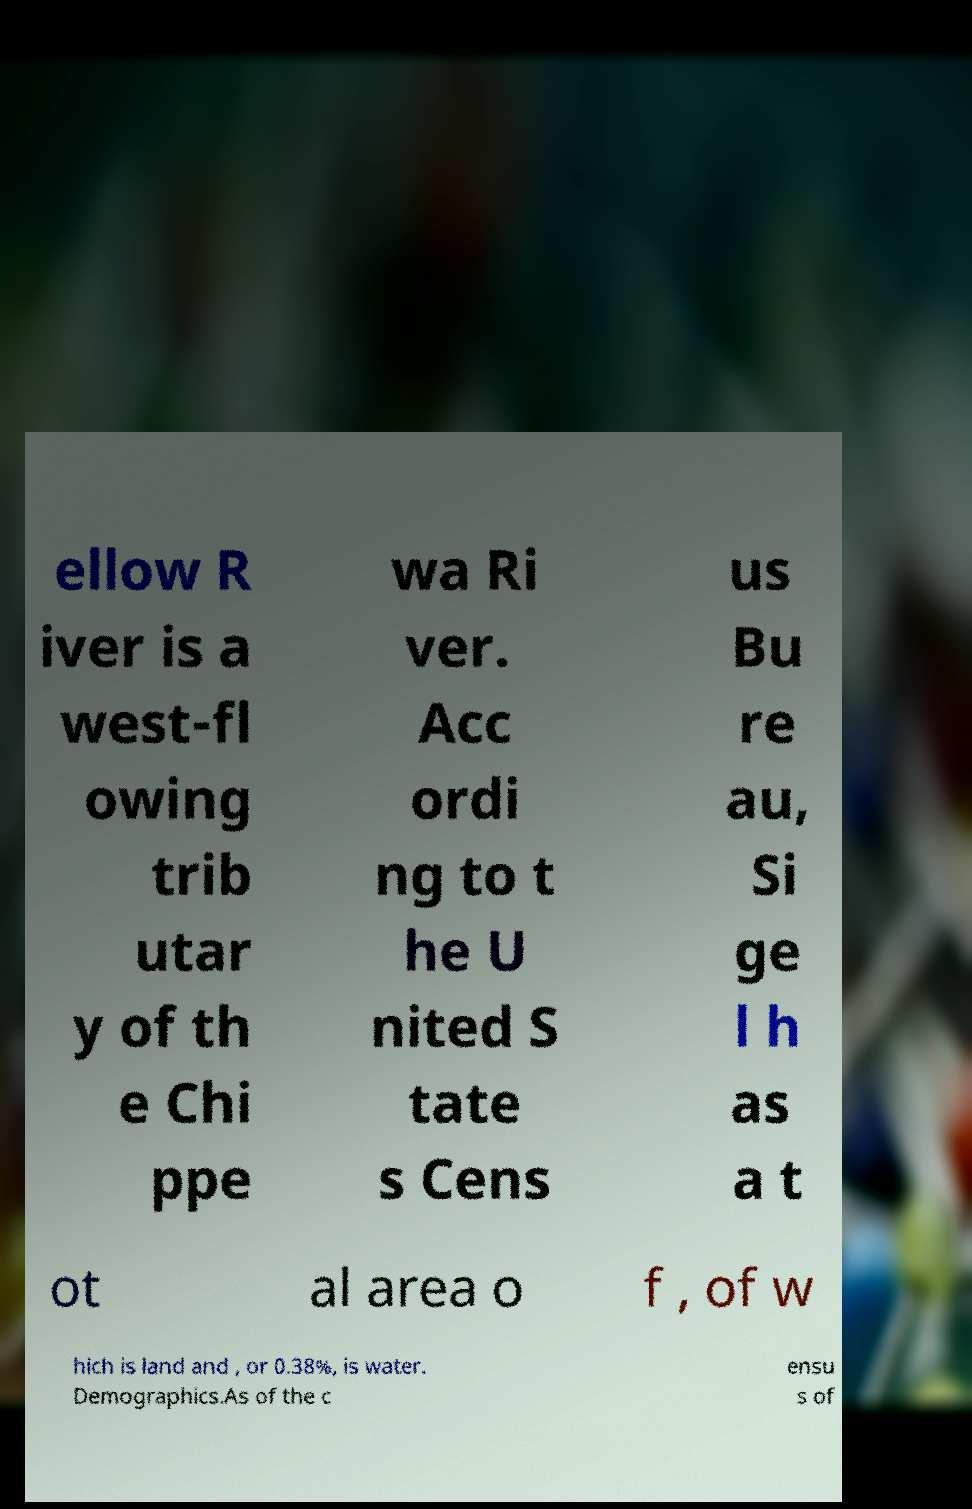Please identify and transcribe the text found in this image. ellow R iver is a west-fl owing trib utar y of th e Chi ppe wa Ri ver. Acc ordi ng to t he U nited S tate s Cens us Bu re au, Si ge l h as a t ot al area o f , of w hich is land and , or 0.38%, is water. Demographics.As of the c ensu s of 